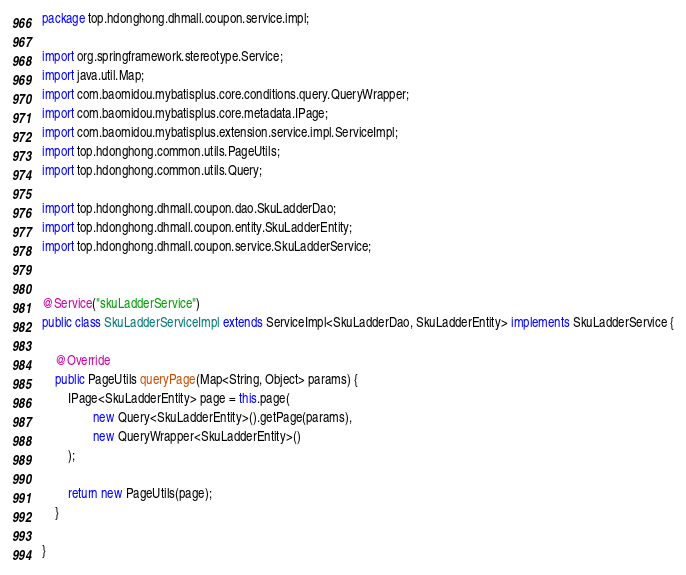Convert code to text. <code><loc_0><loc_0><loc_500><loc_500><_Java_>package top.hdonghong.dhmall.coupon.service.impl;

import org.springframework.stereotype.Service;
import java.util.Map;
import com.baomidou.mybatisplus.core.conditions.query.QueryWrapper;
import com.baomidou.mybatisplus.core.metadata.IPage;
import com.baomidou.mybatisplus.extension.service.impl.ServiceImpl;
import top.hdonghong.common.utils.PageUtils;
import top.hdonghong.common.utils.Query;

import top.hdonghong.dhmall.coupon.dao.SkuLadderDao;
import top.hdonghong.dhmall.coupon.entity.SkuLadderEntity;
import top.hdonghong.dhmall.coupon.service.SkuLadderService;


@Service("skuLadderService")
public class SkuLadderServiceImpl extends ServiceImpl<SkuLadderDao, SkuLadderEntity> implements SkuLadderService {

    @Override
    public PageUtils queryPage(Map<String, Object> params) {
        IPage<SkuLadderEntity> page = this.page(
                new Query<SkuLadderEntity>().getPage(params),
                new QueryWrapper<SkuLadderEntity>()
        );

        return new PageUtils(page);
    }

}</code> 